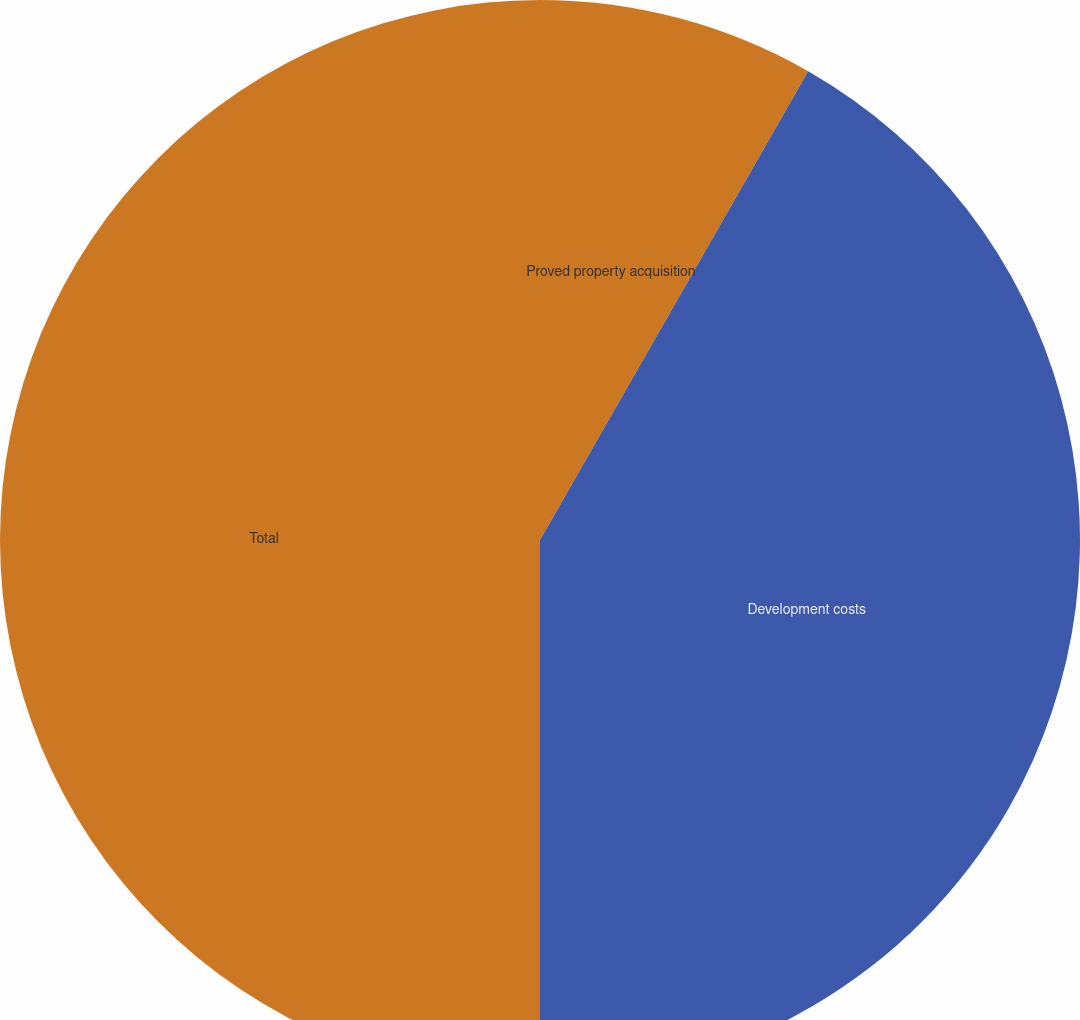Convert chart to OTSL. <chart><loc_0><loc_0><loc_500><loc_500><pie_chart><fcel>Proved property acquisition<fcel>Development costs<fcel>Total<nl><fcel>8.27%<fcel>41.73%<fcel>50.0%<nl></chart> 